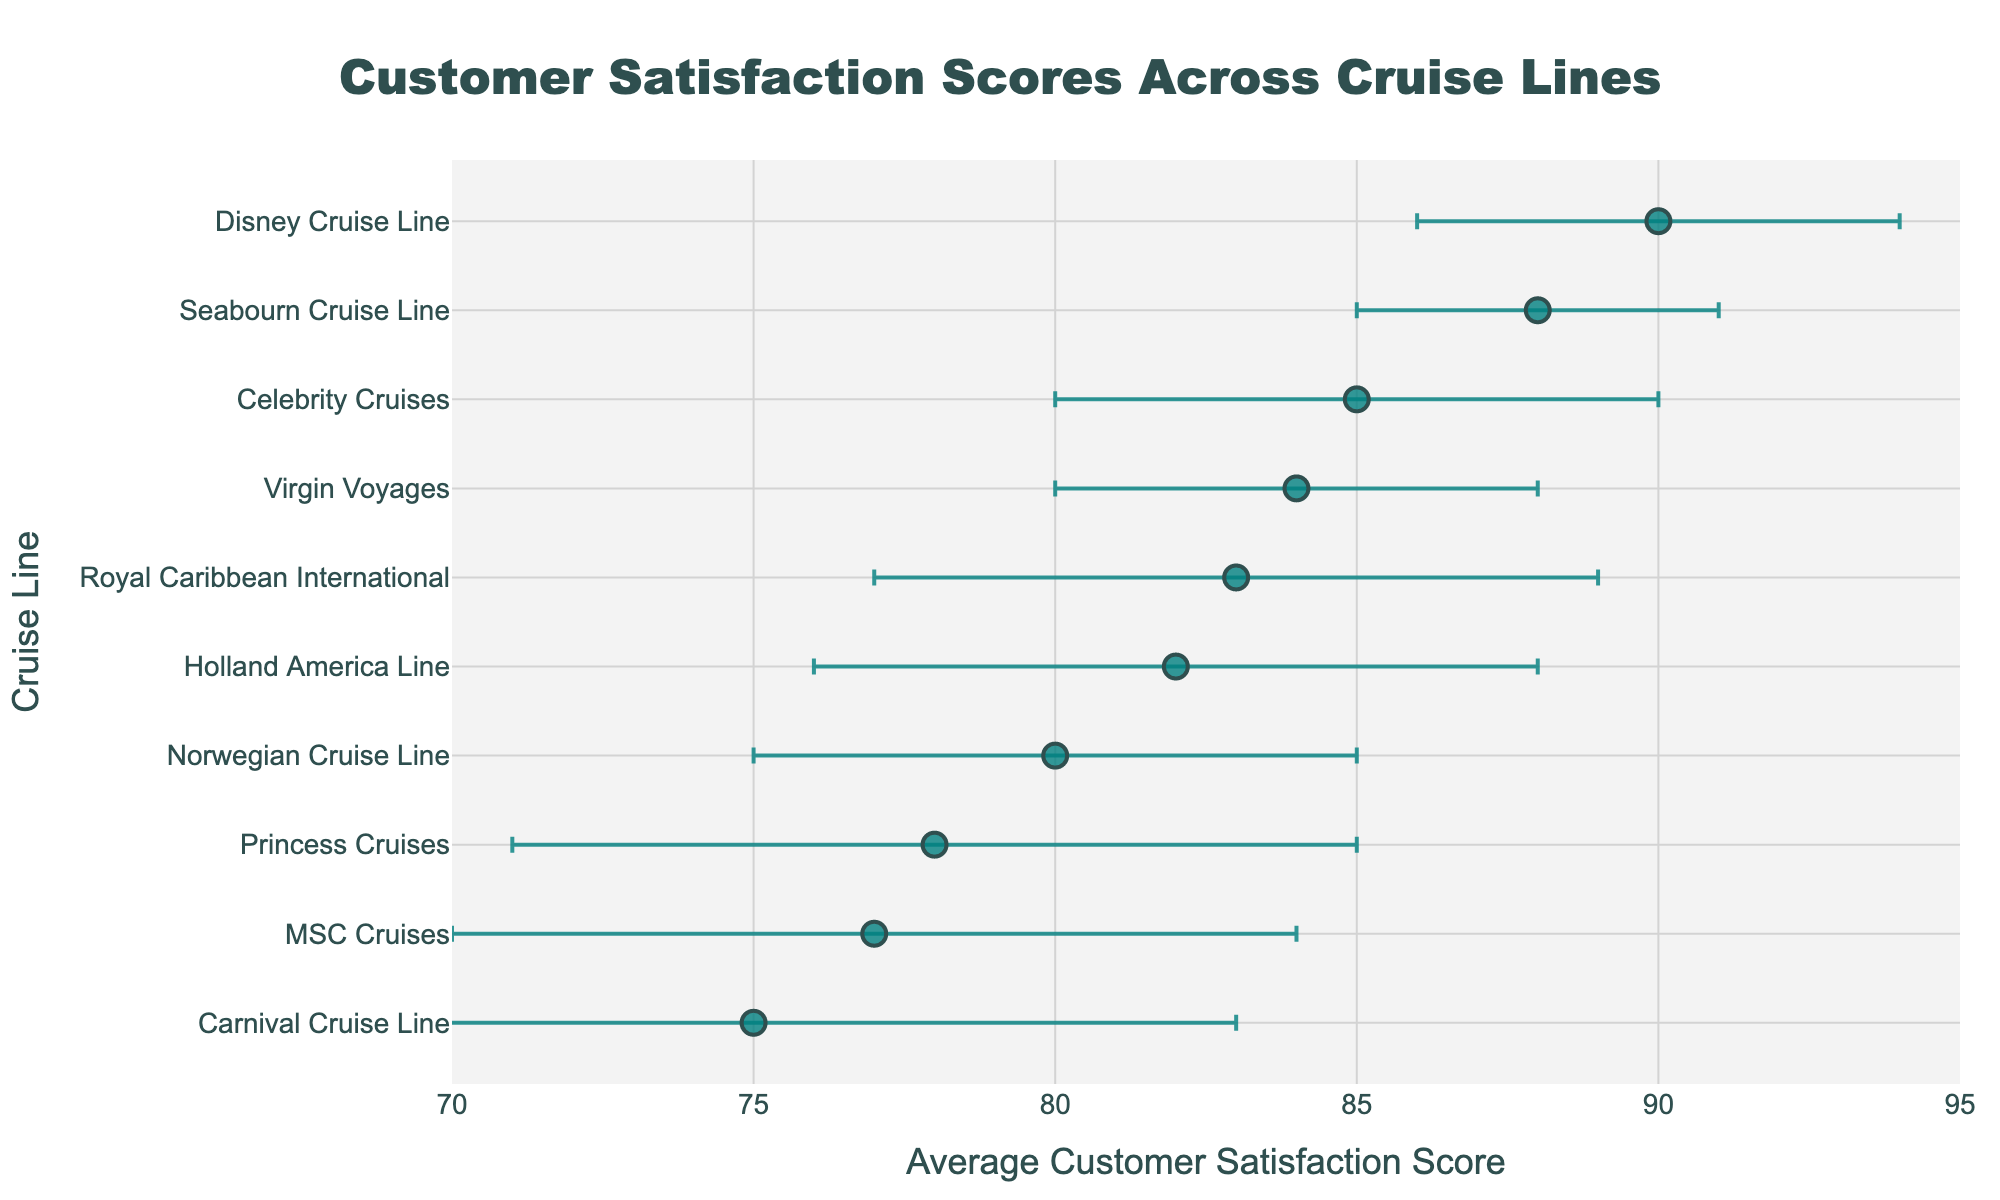What's the title of the plot? The title is usually located at the top of the plot. Here, it is specified in the code segment under the `fig.update_layout` method as `'Customer Satisfaction Scores Across Cruise Lines'`.
Answer: Customer Satisfaction Scores Across Cruise Lines What is the cruise line with the highest average customer satisfaction score? To find this, look at the dot representing the highest value on the x-axis. In the plot, "Disney Cruise Line" has the highest score of 90.
Answer: Disney Cruise Line What is the average customer satisfaction score for Norwegian Cruise Line? Locate "Norwegian Cruise Line" on the y-axis and find the corresponding point along the x-axis. The associated score is 80.
Answer: 80 How many cruise lines have an average customer satisfaction score of 80 or above? Count the number of points to the right of or at 80 on the x-axis. These cruise lines are Royal Caribbean International, Norwegian Cruise Line, Princess Cruises, Holland America Line, Disney Cruise Line, Celebrity Cruises, Seabourn Cruise Line, and Virgin Voyages. There are 8.
Answer: 8 Which cruise line has the largest variability in customer satisfaction scores? The cruise line with the largest error bar represents the highest variability. "Carnival Cruise Line" has the largest standard deviation of 8.
Answer: Carnival Cruise Line What is the difference in average customer satisfaction score between the highest and lowest scoring cruise lines? The highest score is 90 by Disney Cruise Line, and the lowest score is 75 by Carnival Cruise Line. The difference is 90 - 75.
Answer: 15 Which cruise lines have an average satisfaction score within one standard deviation of 85? Identify cruise lines with scores that fall between 80 (85 - 5) and 90 (85 + 5). These are Norwegian Cruise Line, Celebrity Cruises, Seabourn Cruise Line, and Virgin Voyages.
Answer: Norwegian Cruise Line, Celebrity Cruises, Seabourn Cruise Line, Virgin Voyages Do any cruise lines have overlapping error bars? If so, which ones? Overlapping error bars indicate that the ranges of their scores due to variability coincide. For example, `Holland America Line (76 to 88), Princess Cruises (71 to 85), MSC Cruises (70 to 84)` and various combinations within these ranges demonstrate overlap.
Answer: Yes, multiple combinations such as Holland America Line and Princess Cruises, and MSC Cruises Are there any cruise lines with an error bar range entirely within another cruise line's error bar range? Compare the error bars visually. One error bar range lying entirely within another indicates less variability yet similar satisfaction scores. For example, Norwegian Cruise Line's range (75 to 85) is within MSC Cruises' range (70 to 84).
Answer: Yes, for example, Norwegian Cruise Line within MSC Cruises 